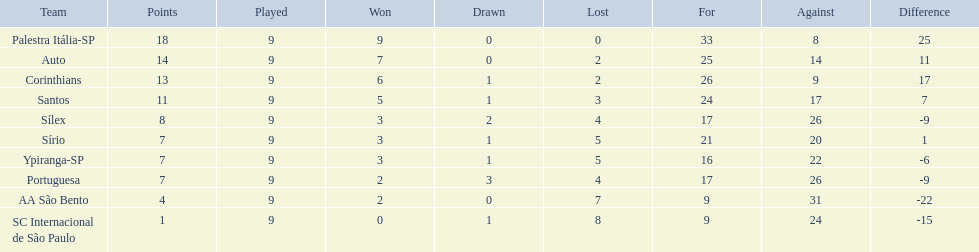How many teams played football in brazil during the year 1926? Palestra Itália-SP, Auto, Corinthians, Santos, Sílex, Sírio, Ypiranga-SP, Portuguesa, AA São Bento, SC Internacional de São Paulo. What was the highest number of games won during the 1926 season? 9. Which team was in the top spot with 9 wins for the 1926 season? Palestra Itália-SP. 